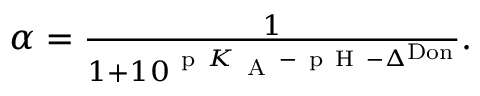Convert formula to latex. <formula><loc_0><loc_0><loc_500><loc_500>\begin{array} { r } { \alpha = \frac { 1 } { 1 + 1 0 ^ { p K _ { A } - p H - \Delta ^ { D o n } } } . } \end{array}</formula> 